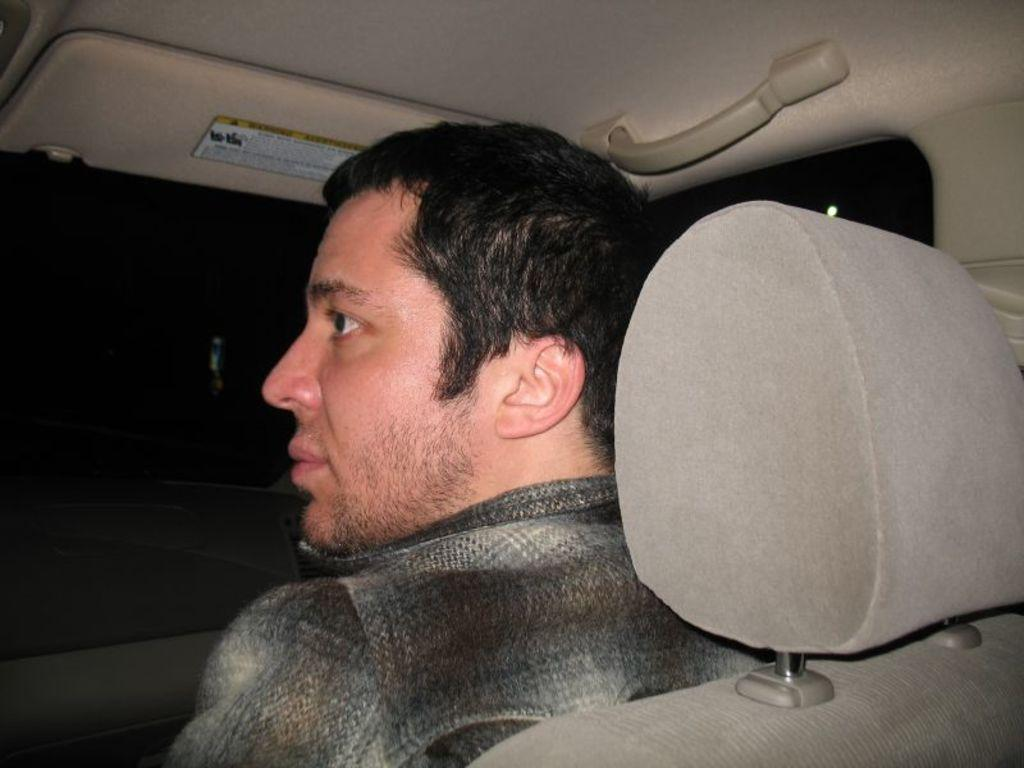Who is present in the image? There is a man in the image. What is the man doing in the image? The man is sitting on a car seat. What is the man wearing in the image? The man is wearing a shirt. What type of juice is the man drinking in the image? There is no juice present in the image; the man is sitting on a car seat and wearing a shirt. 